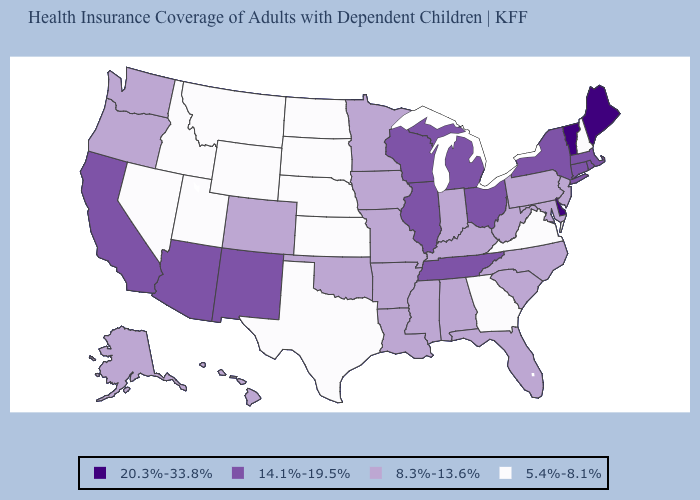Name the states that have a value in the range 20.3%-33.8%?
Answer briefly. Delaware, Maine, Vermont. What is the lowest value in the MidWest?
Be succinct. 5.4%-8.1%. How many symbols are there in the legend?
Keep it brief. 4. Name the states that have a value in the range 20.3%-33.8%?
Be succinct. Delaware, Maine, Vermont. What is the lowest value in states that border Delaware?
Concise answer only. 8.3%-13.6%. Does Vermont have a higher value than Michigan?
Keep it brief. Yes. Does the map have missing data?
Write a very short answer. No. Which states have the lowest value in the USA?
Keep it brief. Georgia, Idaho, Kansas, Montana, Nebraska, Nevada, New Hampshire, North Dakota, South Dakota, Texas, Utah, Virginia, Wyoming. Does Virginia have the lowest value in the USA?
Quick response, please. Yes. What is the highest value in the USA?
Answer briefly. 20.3%-33.8%. What is the value of Oregon?
Be succinct. 8.3%-13.6%. What is the value of Missouri?
Quick response, please. 8.3%-13.6%. What is the highest value in the South ?
Concise answer only. 20.3%-33.8%. Name the states that have a value in the range 8.3%-13.6%?
Concise answer only. Alabama, Alaska, Arkansas, Colorado, Florida, Hawaii, Indiana, Iowa, Kentucky, Louisiana, Maryland, Minnesota, Mississippi, Missouri, New Jersey, North Carolina, Oklahoma, Oregon, Pennsylvania, South Carolina, Washington, West Virginia. What is the lowest value in the South?
Give a very brief answer. 5.4%-8.1%. 